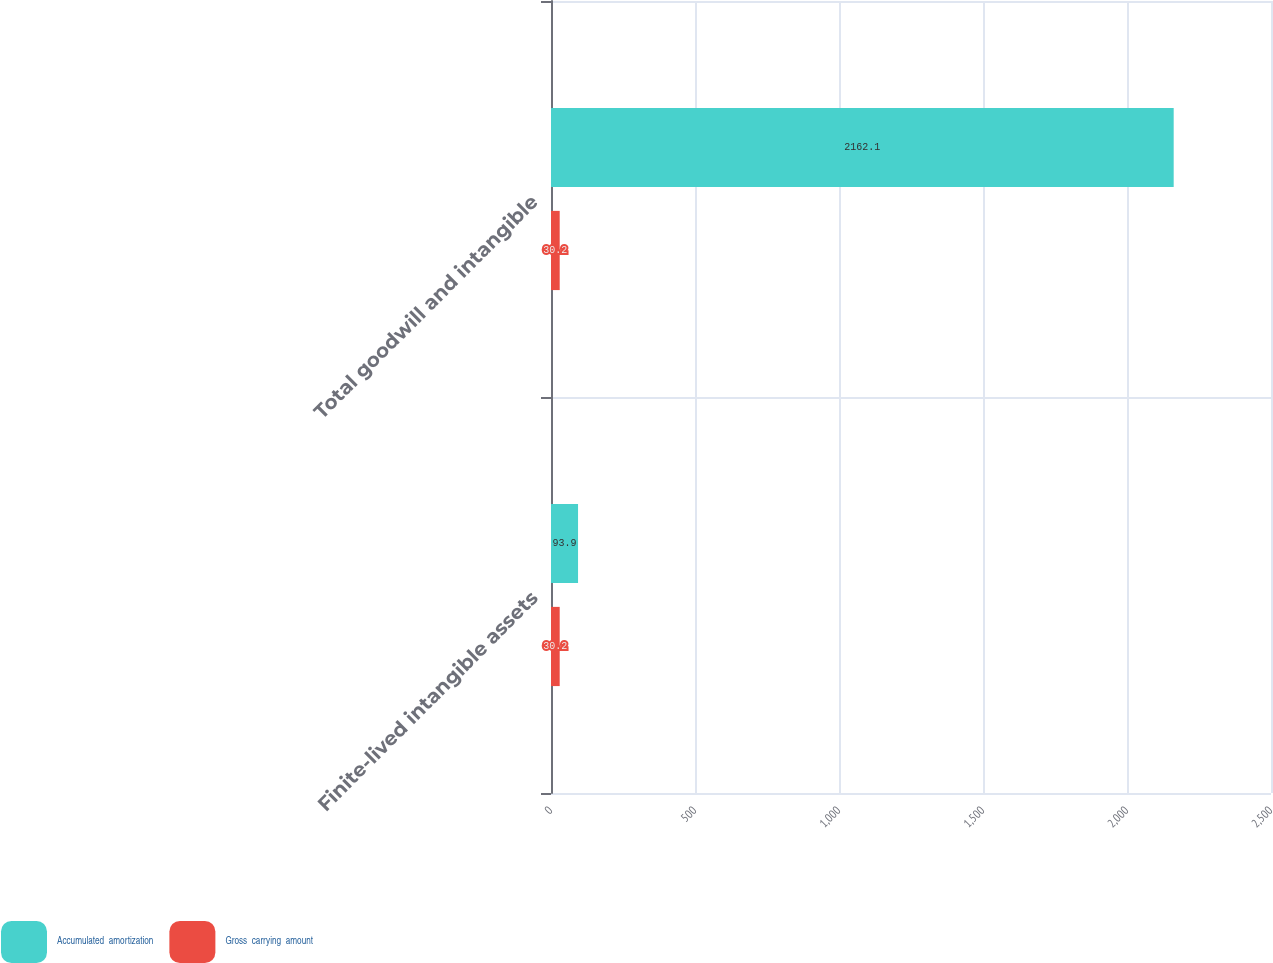Convert chart. <chart><loc_0><loc_0><loc_500><loc_500><stacked_bar_chart><ecel><fcel>Finite-lived intangible assets<fcel>Total goodwill and intangible<nl><fcel>Accumulated  amortization<fcel>93.9<fcel>2162.1<nl><fcel>Gross  carrying  amount<fcel>30.2<fcel>30.2<nl></chart> 